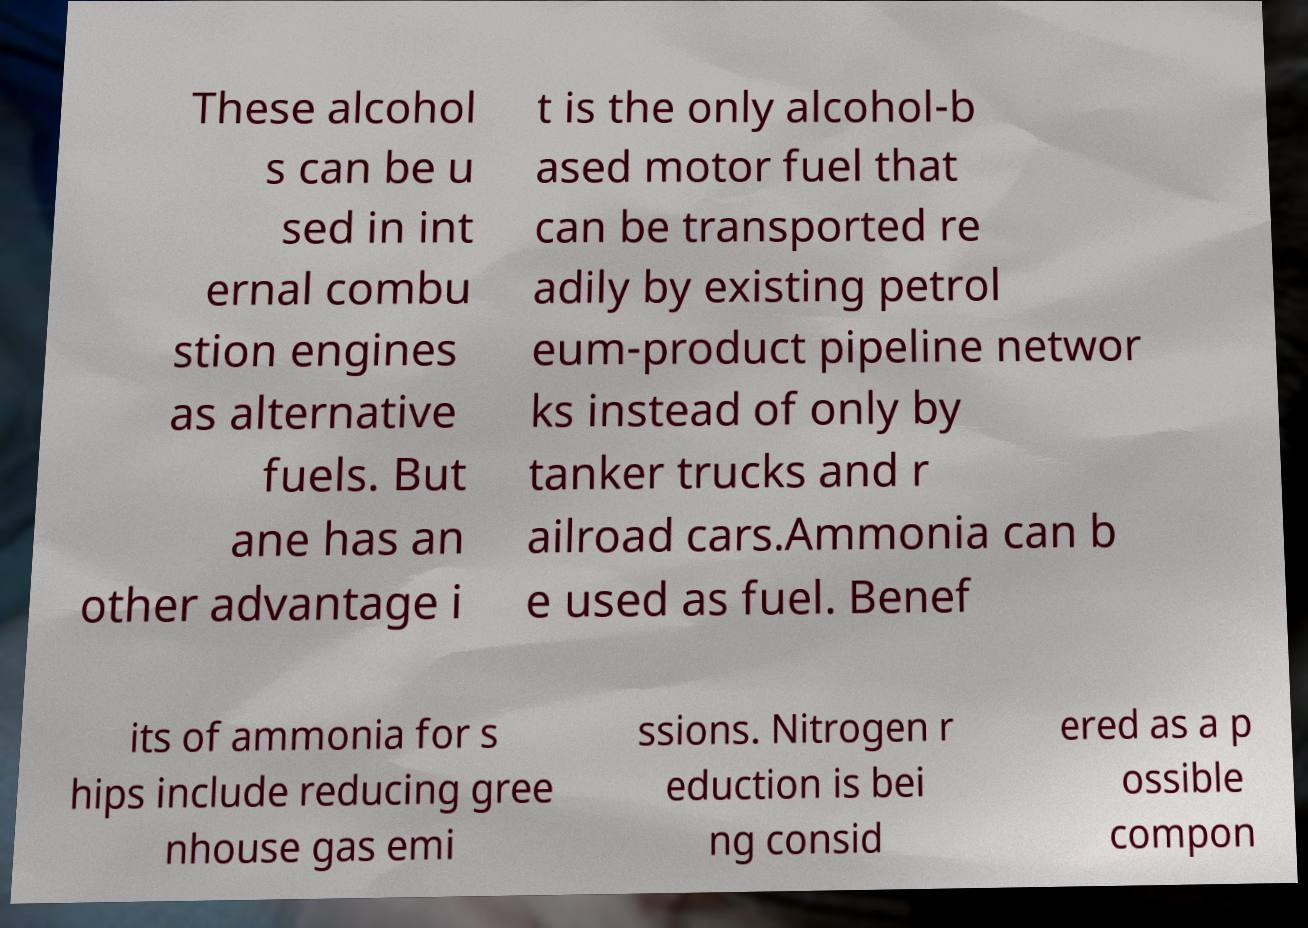I need the written content from this picture converted into text. Can you do that? These alcohol s can be u sed in int ernal combu stion engines as alternative fuels. But ane has an other advantage i t is the only alcohol-b ased motor fuel that can be transported re adily by existing petrol eum-product pipeline networ ks instead of only by tanker trucks and r ailroad cars.Ammonia can b e used as fuel. Benef its of ammonia for s hips include reducing gree nhouse gas emi ssions. Nitrogen r eduction is bei ng consid ered as a p ossible compon 